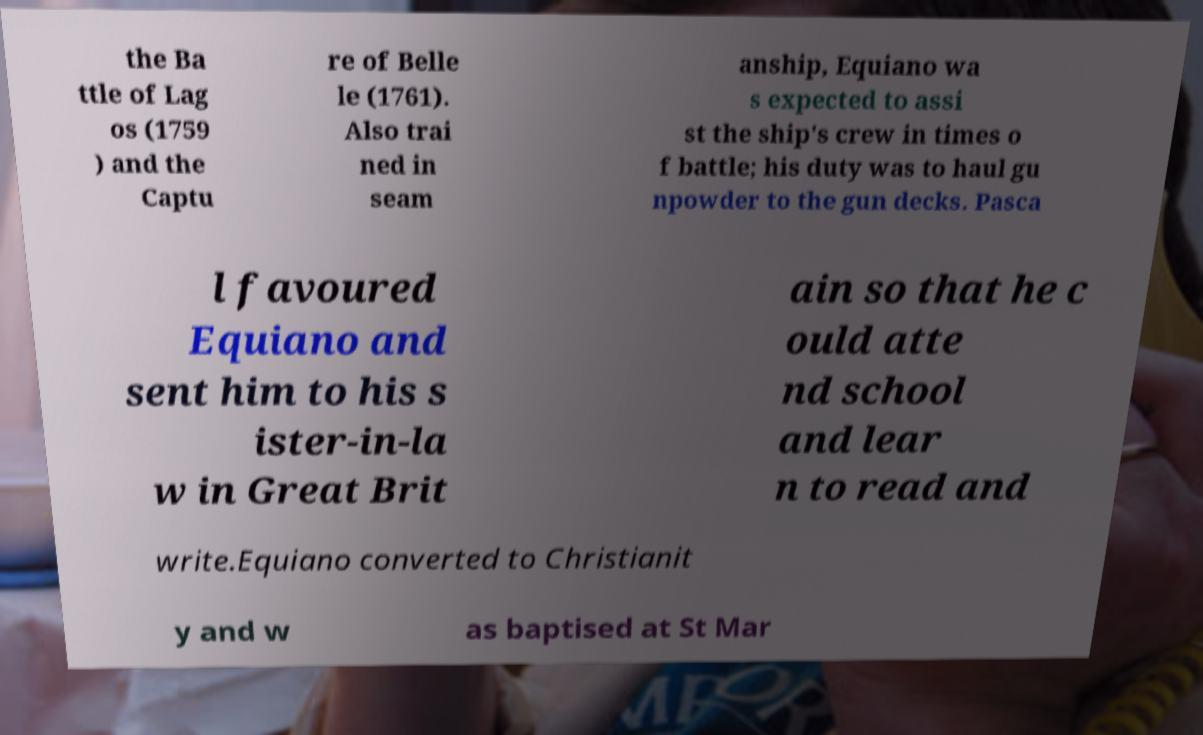I need the written content from this picture converted into text. Can you do that? the Ba ttle of Lag os (1759 ) and the Captu re of Belle le (1761). Also trai ned in seam anship, Equiano wa s expected to assi st the ship's crew in times o f battle; his duty was to haul gu npowder to the gun decks. Pasca l favoured Equiano and sent him to his s ister-in-la w in Great Brit ain so that he c ould atte nd school and lear n to read and write.Equiano converted to Christianit y and w as baptised at St Mar 